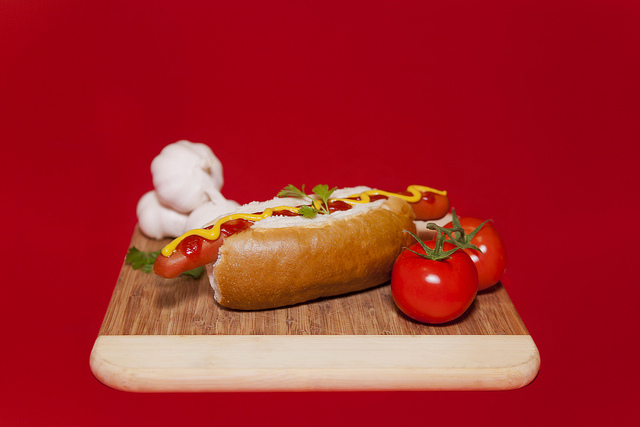Where are the hot dogs? In the image, the hot dog is situated on a wooden cutting board. 